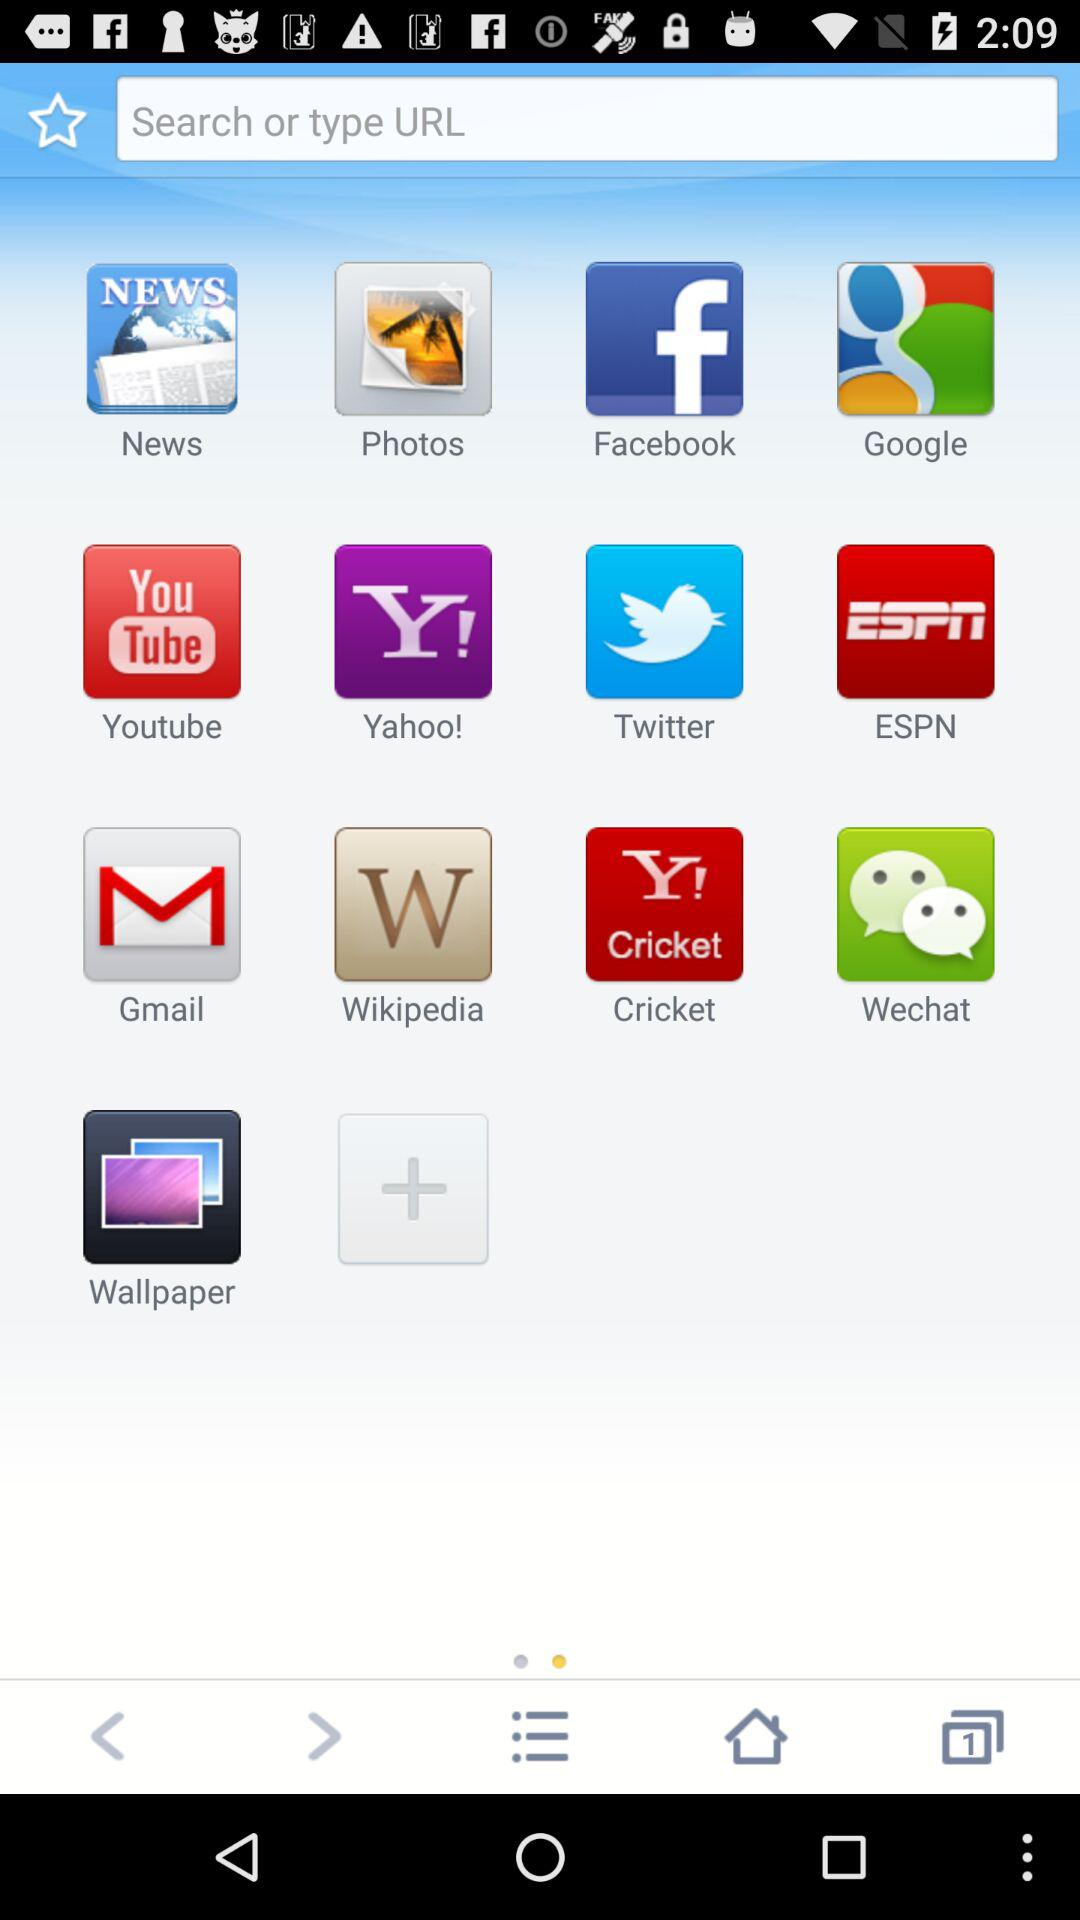How many items have a picture of a sunset with a sticker on it?
Answer the question using a single word or phrase. 1 